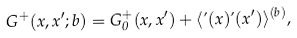<formula> <loc_0><loc_0><loc_500><loc_500>G ^ { + } ( x , x ^ { \prime } ; b ) = G _ { 0 } ^ { + } ( x , x ^ { \prime } ) + \langle \varphi ( x ) \varphi ( x ^ { \prime } ) \rangle ^ { ( b ) } ,</formula> 